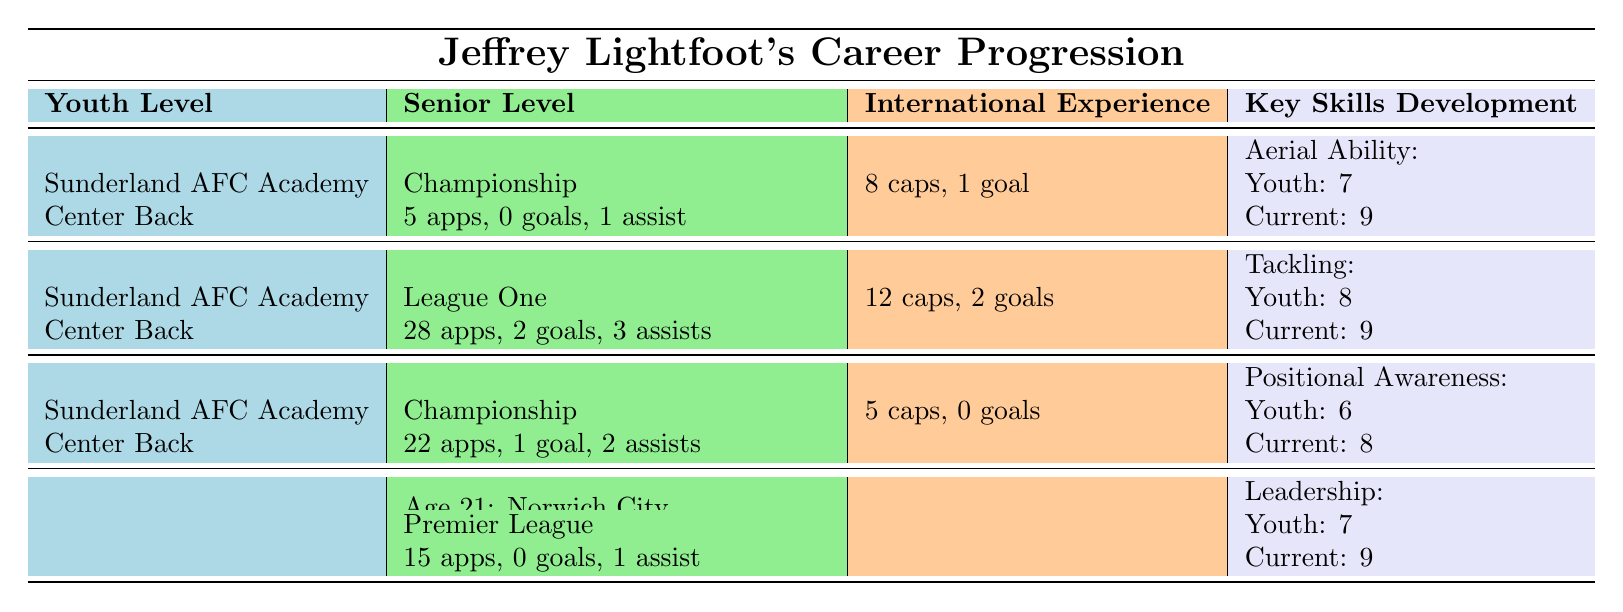What club did Jeffrey Lightfoot play for at age 19? The table indicates that at age 19, Jeffrey Lightfoot played for Accrington Stanley (Loan) in League One.
Answer: Accrington Stanley (Loan) How many appearances did Jeffrey Lightfoot make at Sunderland AFC in the Championship? According to the table, he made 5 appearances at age 18 and 22 appearances at age 20 for Sunderland AFC in the Championship. Adding these gives 5 + 22 = 27 appearances.
Answer: 27 Did Jeffrey Lightfoot score any goals during his time with Norwich City? The table notes that during his time at Norwich City, he made 15 appearances but scored 0 goals.
Answer: No What is the highest achievement noted for Jeffrey Lightfoot at the youth level? The highest achievements mentioned at the youth level include being a semifinalist in the FA Youth Cup at the Under-18 level.
Answer: FA Youth Cup semifinalist What was Jeffrey Lightfoot's international goal tally for the England U18 team? From the table, it shows that Jeffrey Lightfoot had 12 caps and scored 2 goals while playing for the England U18 team.
Answer: 2 Is Jeffrey Lightfoot's current rating for Positional Awareness higher than his youth rating? The table shows that his youth rating for Positional Awareness is 6 and his current rating is 8, which is higher.
Answer: Yes What were Jeffrey Lightfoot's total goals in league matches across all clubs mentioned at age 19? He scored 2 goals while on loan at Accrington Stanley at age 19; he did not score any goals while at Sunderland AFC. Therefore, total goals at age 19 is 2.
Answer: 2 Compare Jeffrey Lightfoot's achievements at the Under-15 and Under-18 levels. Which age group had more significant achievements? At Under-15, he was called up for England U15 and won the Nike Academy Cup. At Under-18, he was a semifinalist in the FA Youth Cup and made it to the Premier League U18 Team of the Season, which are more significant achievements.
Answer: Under-18 had more significant achievements 